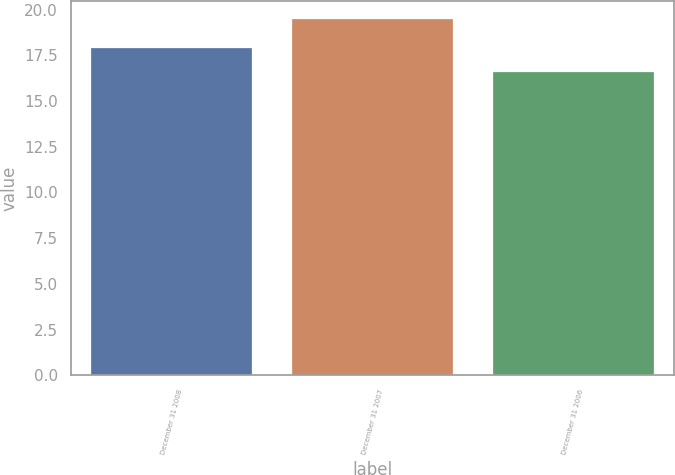<chart> <loc_0><loc_0><loc_500><loc_500><bar_chart><fcel>December 31 2008<fcel>December 31 2007<fcel>December 31 2006<nl><fcel>17.9<fcel>19.5<fcel>16.6<nl></chart> 